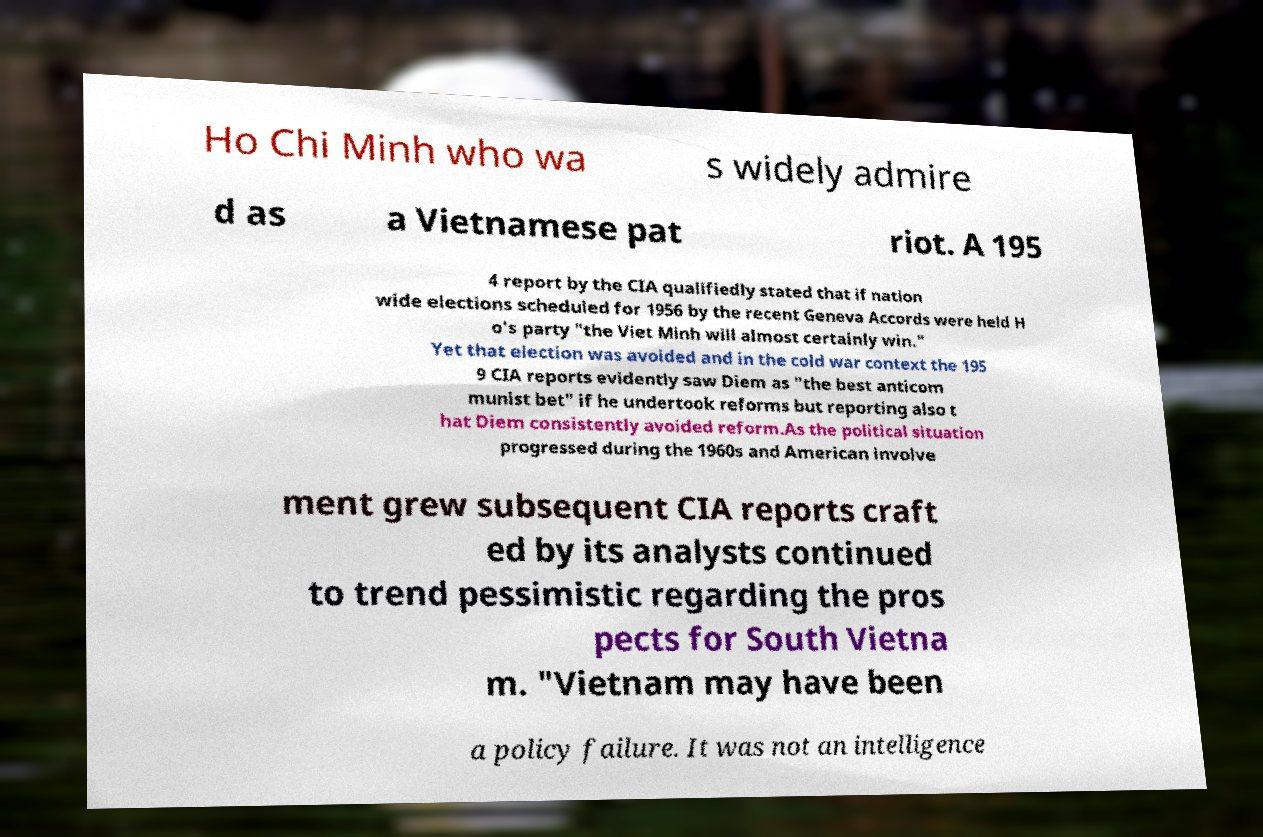Could you assist in decoding the text presented in this image and type it out clearly? Ho Chi Minh who wa s widely admire d as a Vietnamese pat riot. A 195 4 report by the CIA qualifiedly stated that if nation wide elections scheduled for 1956 by the recent Geneva Accords were held H o's party "the Viet Minh will almost certainly win." Yet that election was avoided and in the cold war context the 195 9 CIA reports evidently saw Diem as "the best anticom munist bet" if he undertook reforms but reporting also t hat Diem consistently avoided reform.As the political situation progressed during the 1960s and American involve ment grew subsequent CIA reports craft ed by its analysts continued to trend pessimistic regarding the pros pects for South Vietna m. "Vietnam may have been a policy failure. It was not an intelligence 